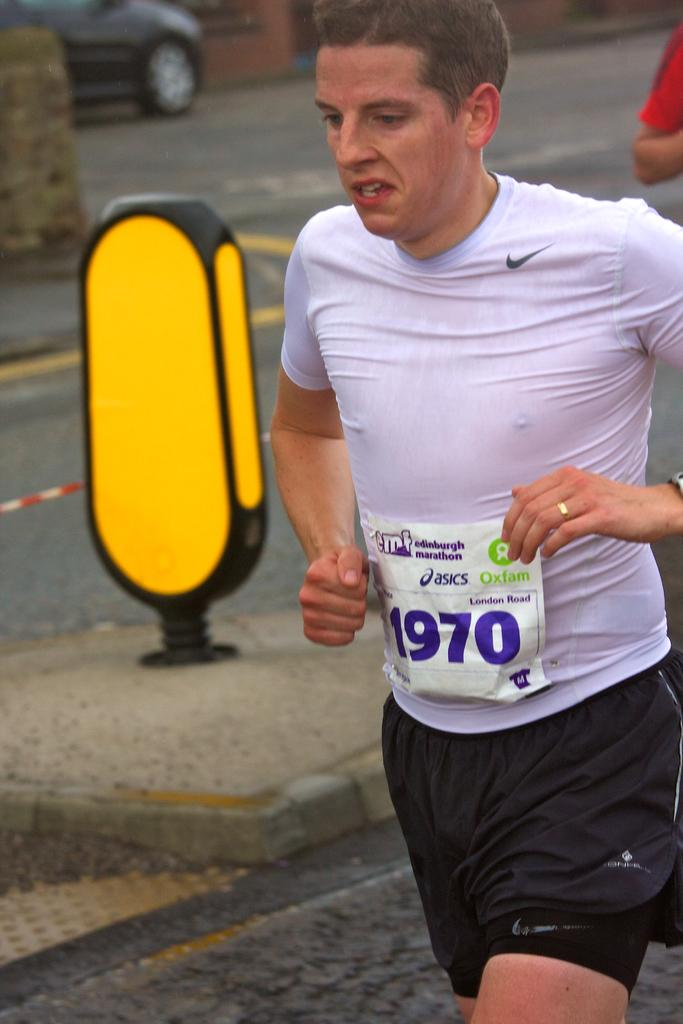Who is present in the image? There is a man in the image. What is the man wearing? The man is wearing a white t-shirt. What is the man holding in the image? The man is holding a poster. What can be seen in the background of the image? There is a black color car in the background of the image. What type of argument can be seen between the cows in the image? There are no cows present in the image, so it is not possible to observe any arguments between them. What kind of seed is being planted by the man in the image? There is no seed or planting activity depicted in the image; the man is holding a poster. 